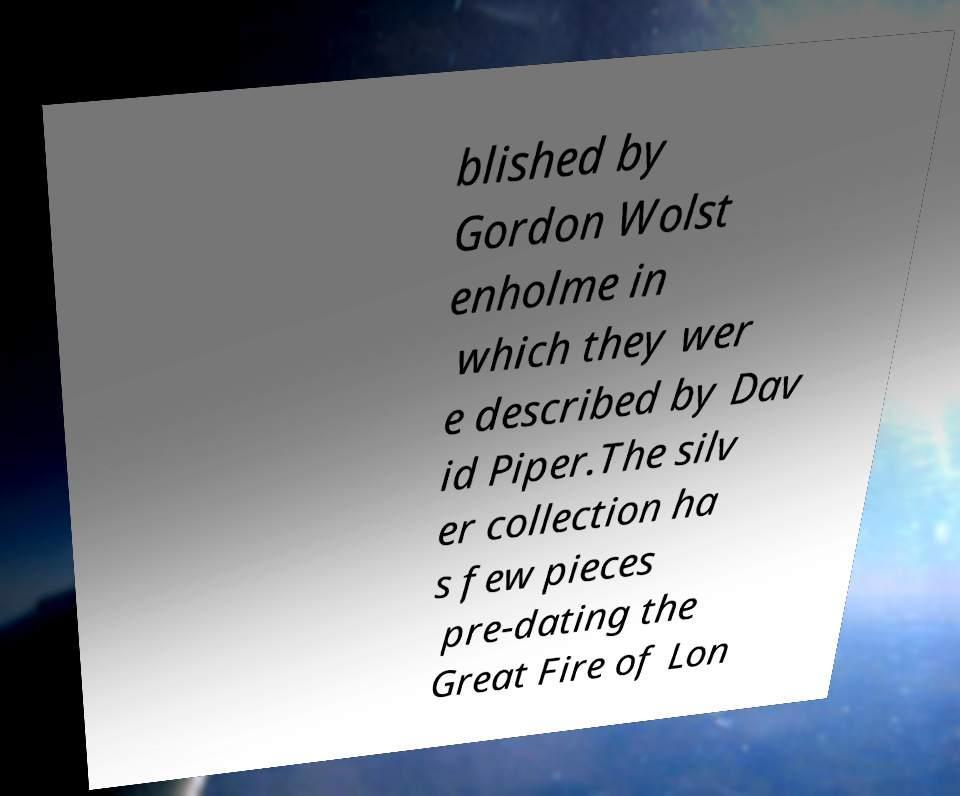For documentation purposes, I need the text within this image transcribed. Could you provide that? blished by Gordon Wolst enholme in which they wer e described by Dav id Piper.The silv er collection ha s few pieces pre-dating the Great Fire of Lon 